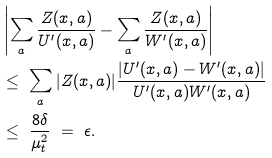<formula> <loc_0><loc_0><loc_500><loc_500>& \left | \sum _ { a } \frac { Z ( x , a ) } { U ^ { \prime } ( x , a ) } - \sum _ { a } \frac { Z ( x , a ) } { W ^ { \prime } ( x , a ) } \right | \\ & \leq \ \sum _ { a } | Z ( x , a ) | \frac { | U ^ { \prime } ( x , a ) - W ^ { \prime } ( x , a ) | } { U ^ { \prime } ( x , a ) W ^ { \prime } ( x , a ) } \\ & \leq \ \frac { 8 \delta } { \mu _ { t } ^ { 2 } } \ = \ \epsilon .</formula> 